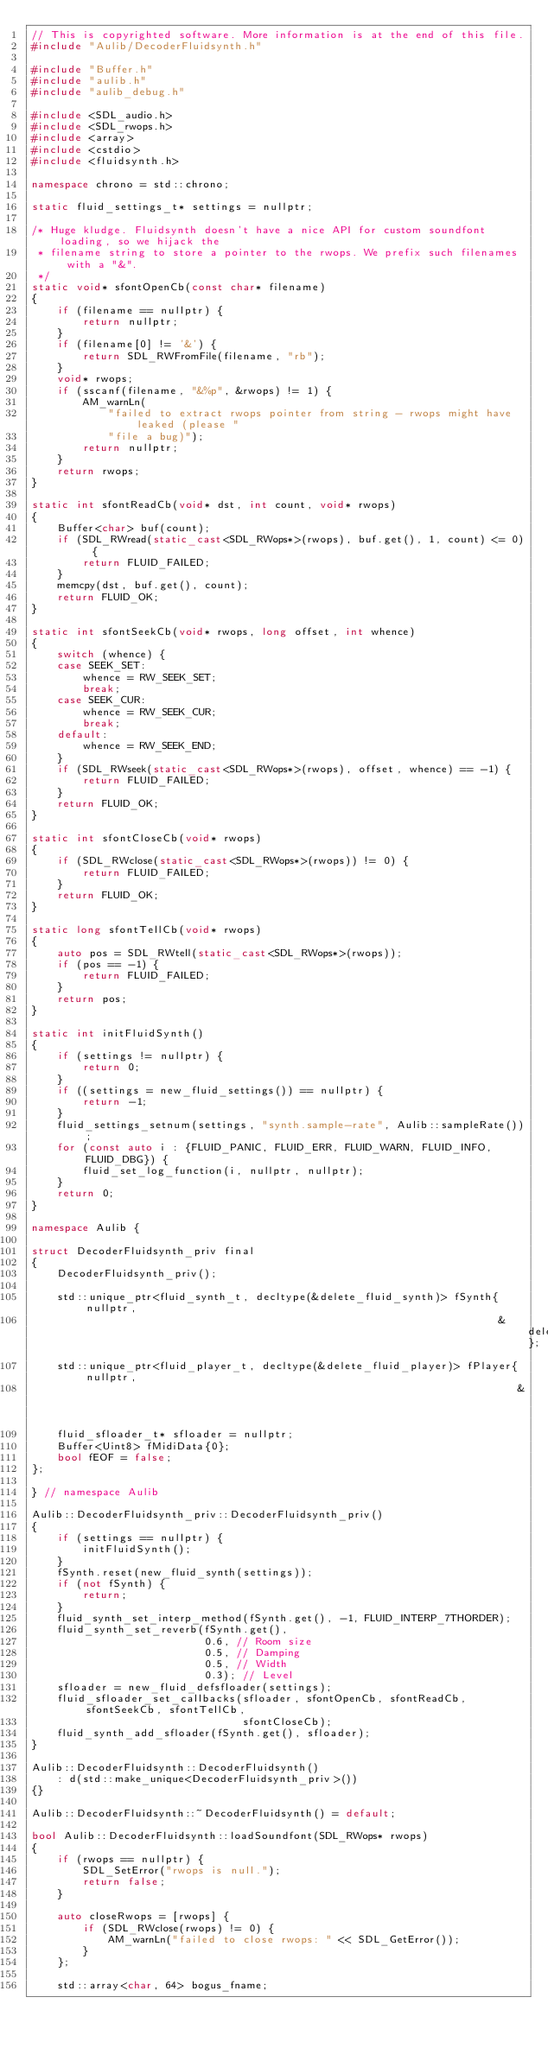<code> <loc_0><loc_0><loc_500><loc_500><_C++_>// This is copyrighted software. More information is at the end of this file.
#include "Aulib/DecoderFluidsynth.h"

#include "Buffer.h"
#include "aulib.h"
#include "aulib_debug.h"

#include <SDL_audio.h>
#include <SDL_rwops.h>
#include <array>
#include <cstdio>
#include <fluidsynth.h>

namespace chrono = std::chrono;

static fluid_settings_t* settings = nullptr;

/* Huge kludge. Fluidsynth doesn't have a nice API for custom soundfont loading, so we hijack the
 * filename string to store a pointer to the rwops. We prefix such filenames with a "&".
 */
static void* sfontOpenCb(const char* filename)
{
    if (filename == nullptr) {
        return nullptr;
    }
    if (filename[0] != '&') {
        return SDL_RWFromFile(filename, "rb");
    }
    void* rwops;
    if (sscanf(filename, "&%p", &rwops) != 1) {
        AM_warnLn(
            "failed to extract rwops pointer from string - rwops might have leaked (please "
            "file a bug)");
        return nullptr;
    }
    return rwops;
}

static int sfontReadCb(void* dst, int count, void* rwops)
{
    Buffer<char> buf(count);
    if (SDL_RWread(static_cast<SDL_RWops*>(rwops), buf.get(), 1, count) <= 0) {
        return FLUID_FAILED;
    }
    memcpy(dst, buf.get(), count);
    return FLUID_OK;
}

static int sfontSeekCb(void* rwops, long offset, int whence)
{
    switch (whence) {
    case SEEK_SET:
        whence = RW_SEEK_SET;
        break;
    case SEEK_CUR:
        whence = RW_SEEK_CUR;
        break;
    default:
        whence = RW_SEEK_END;
    }
    if (SDL_RWseek(static_cast<SDL_RWops*>(rwops), offset, whence) == -1) {
        return FLUID_FAILED;
    }
    return FLUID_OK;
}

static int sfontCloseCb(void* rwops)
{
    if (SDL_RWclose(static_cast<SDL_RWops*>(rwops)) != 0) {
        return FLUID_FAILED;
    }
    return FLUID_OK;
}

static long sfontTellCb(void* rwops)
{
    auto pos = SDL_RWtell(static_cast<SDL_RWops*>(rwops));
    if (pos == -1) {
        return FLUID_FAILED;
    }
    return pos;
}

static int initFluidSynth()
{
    if (settings != nullptr) {
        return 0;
    }
    if ((settings = new_fluid_settings()) == nullptr) {
        return -1;
    }
    fluid_settings_setnum(settings, "synth.sample-rate", Aulib::sampleRate());
    for (const auto i : {FLUID_PANIC, FLUID_ERR, FLUID_WARN, FLUID_INFO, FLUID_DBG}) {
        fluid_set_log_function(i, nullptr, nullptr);
    }
    return 0;
}

namespace Aulib {

struct DecoderFluidsynth_priv final
{
    DecoderFluidsynth_priv();

    std::unique_ptr<fluid_synth_t, decltype(&delete_fluid_synth)> fSynth{nullptr,
                                                                         &delete_fluid_synth};
    std::unique_ptr<fluid_player_t, decltype(&delete_fluid_player)> fPlayer{nullptr,
                                                                            &delete_fluid_player};
    fluid_sfloader_t* sfloader = nullptr;
    Buffer<Uint8> fMidiData{0};
    bool fEOF = false;
};

} // namespace Aulib

Aulib::DecoderFluidsynth_priv::DecoderFluidsynth_priv()
{
    if (settings == nullptr) {
        initFluidSynth();
    }
    fSynth.reset(new_fluid_synth(settings));
    if (not fSynth) {
        return;
    }
    fluid_synth_set_interp_method(fSynth.get(), -1, FLUID_INTERP_7THORDER);
    fluid_synth_set_reverb(fSynth.get(),
                           0.6, // Room size
                           0.5, // Damping
                           0.5, // Width
                           0.3); // Level
    sfloader = new_fluid_defsfloader(settings);
    fluid_sfloader_set_callbacks(sfloader, sfontOpenCb, sfontReadCb, sfontSeekCb, sfontTellCb,
                                 sfontCloseCb);
    fluid_synth_add_sfloader(fSynth.get(), sfloader);
}

Aulib::DecoderFluidsynth::DecoderFluidsynth()
    : d(std::make_unique<DecoderFluidsynth_priv>())
{}

Aulib::DecoderFluidsynth::~DecoderFluidsynth() = default;

bool Aulib::DecoderFluidsynth::loadSoundfont(SDL_RWops* rwops)
{
    if (rwops == nullptr) {
        SDL_SetError("rwops is null.");
        return false;
    }

    auto closeRwops = [rwops] {
        if (SDL_RWclose(rwops) != 0) {
            AM_warnLn("failed to close rwops: " << SDL_GetError());
        }
    };

    std::array<char, 64> bogus_fname;</code> 